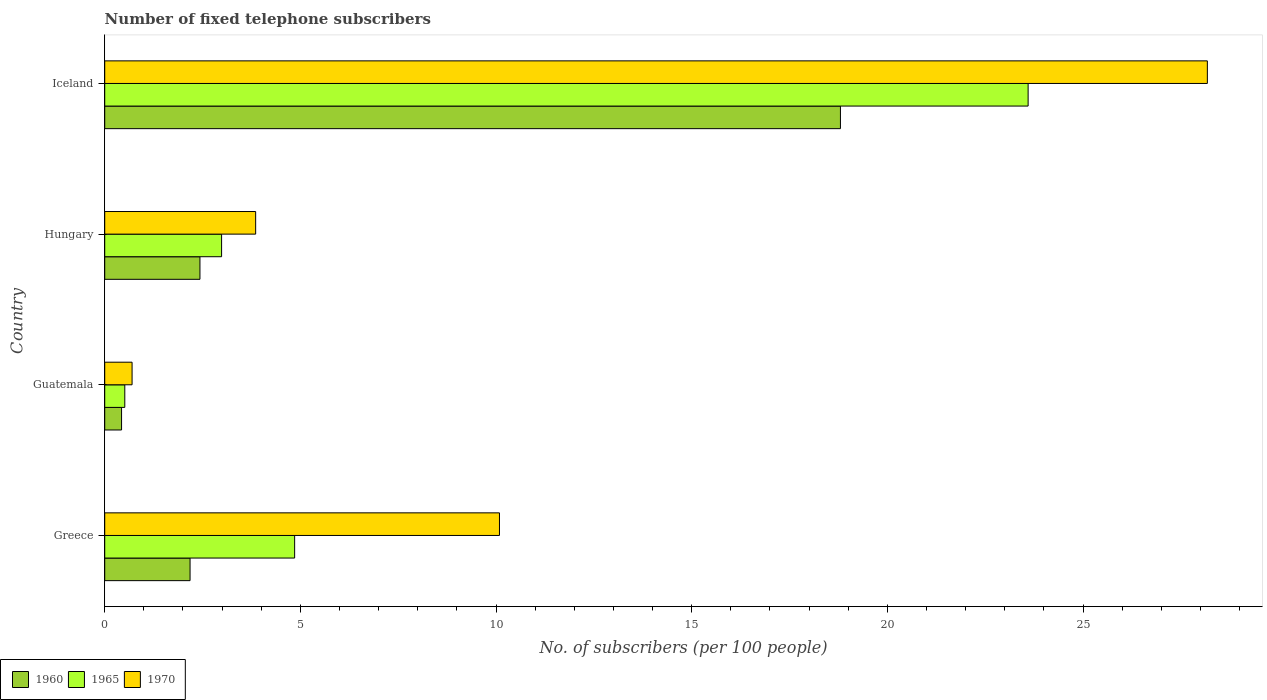How many different coloured bars are there?
Your response must be concise. 3. How many bars are there on the 4th tick from the bottom?
Your response must be concise. 3. What is the label of the 2nd group of bars from the top?
Make the answer very short. Hungary. In how many cases, is the number of bars for a given country not equal to the number of legend labels?
Offer a very short reply. 0. What is the number of fixed telephone subscribers in 1965 in Guatemala?
Ensure brevity in your answer.  0.51. Across all countries, what is the maximum number of fixed telephone subscribers in 1970?
Provide a succinct answer. 28.18. Across all countries, what is the minimum number of fixed telephone subscribers in 1965?
Your response must be concise. 0.51. In which country was the number of fixed telephone subscribers in 1960 maximum?
Offer a terse response. Iceland. In which country was the number of fixed telephone subscribers in 1965 minimum?
Provide a succinct answer. Guatemala. What is the total number of fixed telephone subscribers in 1970 in the graph?
Keep it short and to the point. 42.82. What is the difference between the number of fixed telephone subscribers in 1965 in Guatemala and that in Iceland?
Provide a succinct answer. -23.08. What is the difference between the number of fixed telephone subscribers in 1970 in Guatemala and the number of fixed telephone subscribers in 1965 in Greece?
Ensure brevity in your answer.  -4.15. What is the average number of fixed telephone subscribers in 1960 per country?
Your response must be concise. 5.96. What is the difference between the number of fixed telephone subscribers in 1960 and number of fixed telephone subscribers in 1970 in Iceland?
Offer a terse response. -9.38. In how many countries, is the number of fixed telephone subscribers in 1970 greater than 26 ?
Your response must be concise. 1. What is the ratio of the number of fixed telephone subscribers in 1970 in Greece to that in Guatemala?
Keep it short and to the point. 14.43. Is the number of fixed telephone subscribers in 1965 in Greece less than that in Hungary?
Give a very brief answer. No. What is the difference between the highest and the second highest number of fixed telephone subscribers in 1960?
Offer a very short reply. 16.37. What is the difference between the highest and the lowest number of fixed telephone subscribers in 1960?
Provide a succinct answer. 18.37. What does the 3rd bar from the bottom in Greece represents?
Provide a succinct answer. 1970. How many bars are there?
Your response must be concise. 12. Are all the bars in the graph horizontal?
Offer a very short reply. Yes. How many countries are there in the graph?
Ensure brevity in your answer.  4. Does the graph contain any zero values?
Provide a short and direct response. No. How many legend labels are there?
Offer a terse response. 3. What is the title of the graph?
Offer a terse response. Number of fixed telephone subscribers. Does "2011" appear as one of the legend labels in the graph?
Your answer should be very brief. No. What is the label or title of the X-axis?
Ensure brevity in your answer.  No. of subscribers (per 100 people). What is the label or title of the Y-axis?
Make the answer very short. Country. What is the No. of subscribers (per 100 people) in 1960 in Greece?
Provide a succinct answer. 2.18. What is the No. of subscribers (per 100 people) of 1965 in Greece?
Provide a succinct answer. 4.85. What is the No. of subscribers (per 100 people) of 1970 in Greece?
Provide a short and direct response. 10.09. What is the No. of subscribers (per 100 people) in 1960 in Guatemala?
Your answer should be compact. 0.43. What is the No. of subscribers (per 100 people) in 1965 in Guatemala?
Make the answer very short. 0.51. What is the No. of subscribers (per 100 people) in 1970 in Guatemala?
Provide a succinct answer. 0.7. What is the No. of subscribers (per 100 people) in 1960 in Hungary?
Your answer should be very brief. 2.43. What is the No. of subscribers (per 100 people) in 1965 in Hungary?
Keep it short and to the point. 2.99. What is the No. of subscribers (per 100 people) of 1970 in Hungary?
Your answer should be very brief. 3.86. What is the No. of subscribers (per 100 people) of 1960 in Iceland?
Your response must be concise. 18.8. What is the No. of subscribers (per 100 people) of 1965 in Iceland?
Provide a succinct answer. 23.6. What is the No. of subscribers (per 100 people) of 1970 in Iceland?
Ensure brevity in your answer.  28.18. Across all countries, what is the maximum No. of subscribers (per 100 people) in 1960?
Your response must be concise. 18.8. Across all countries, what is the maximum No. of subscribers (per 100 people) in 1965?
Your answer should be compact. 23.6. Across all countries, what is the maximum No. of subscribers (per 100 people) in 1970?
Keep it short and to the point. 28.18. Across all countries, what is the minimum No. of subscribers (per 100 people) of 1960?
Your answer should be compact. 0.43. Across all countries, what is the minimum No. of subscribers (per 100 people) of 1965?
Keep it short and to the point. 0.51. Across all countries, what is the minimum No. of subscribers (per 100 people) in 1970?
Your answer should be compact. 0.7. What is the total No. of subscribers (per 100 people) of 1960 in the graph?
Keep it short and to the point. 23.85. What is the total No. of subscribers (per 100 people) of 1965 in the graph?
Make the answer very short. 31.95. What is the total No. of subscribers (per 100 people) in 1970 in the graph?
Your answer should be very brief. 42.82. What is the difference between the No. of subscribers (per 100 people) of 1960 in Greece and that in Guatemala?
Your response must be concise. 1.75. What is the difference between the No. of subscribers (per 100 people) of 1965 in Greece and that in Guatemala?
Make the answer very short. 4.34. What is the difference between the No. of subscribers (per 100 people) in 1970 in Greece and that in Guatemala?
Offer a terse response. 9.39. What is the difference between the No. of subscribers (per 100 people) of 1960 in Greece and that in Hungary?
Offer a terse response. -0.25. What is the difference between the No. of subscribers (per 100 people) in 1965 in Greece and that in Hungary?
Offer a very short reply. 1.87. What is the difference between the No. of subscribers (per 100 people) in 1970 in Greece and that in Hungary?
Provide a short and direct response. 6.23. What is the difference between the No. of subscribers (per 100 people) in 1960 in Greece and that in Iceland?
Provide a short and direct response. -16.62. What is the difference between the No. of subscribers (per 100 people) in 1965 in Greece and that in Iceland?
Keep it short and to the point. -18.74. What is the difference between the No. of subscribers (per 100 people) of 1970 in Greece and that in Iceland?
Your answer should be very brief. -18.09. What is the difference between the No. of subscribers (per 100 people) of 1960 in Guatemala and that in Hungary?
Your response must be concise. -2. What is the difference between the No. of subscribers (per 100 people) in 1965 in Guatemala and that in Hungary?
Offer a very short reply. -2.47. What is the difference between the No. of subscribers (per 100 people) in 1970 in Guatemala and that in Hungary?
Ensure brevity in your answer.  -3.16. What is the difference between the No. of subscribers (per 100 people) in 1960 in Guatemala and that in Iceland?
Make the answer very short. -18.37. What is the difference between the No. of subscribers (per 100 people) of 1965 in Guatemala and that in Iceland?
Your answer should be very brief. -23.08. What is the difference between the No. of subscribers (per 100 people) of 1970 in Guatemala and that in Iceland?
Provide a short and direct response. -27.48. What is the difference between the No. of subscribers (per 100 people) of 1960 in Hungary and that in Iceland?
Give a very brief answer. -16.37. What is the difference between the No. of subscribers (per 100 people) in 1965 in Hungary and that in Iceland?
Give a very brief answer. -20.61. What is the difference between the No. of subscribers (per 100 people) in 1970 in Hungary and that in Iceland?
Your answer should be compact. -24.32. What is the difference between the No. of subscribers (per 100 people) of 1960 in Greece and the No. of subscribers (per 100 people) of 1965 in Guatemala?
Provide a short and direct response. 1.67. What is the difference between the No. of subscribers (per 100 people) of 1960 in Greece and the No. of subscribers (per 100 people) of 1970 in Guatemala?
Ensure brevity in your answer.  1.48. What is the difference between the No. of subscribers (per 100 people) in 1965 in Greece and the No. of subscribers (per 100 people) in 1970 in Guatemala?
Provide a short and direct response. 4.15. What is the difference between the No. of subscribers (per 100 people) of 1960 in Greece and the No. of subscribers (per 100 people) of 1965 in Hungary?
Your answer should be compact. -0.81. What is the difference between the No. of subscribers (per 100 people) of 1960 in Greece and the No. of subscribers (per 100 people) of 1970 in Hungary?
Your answer should be very brief. -1.68. What is the difference between the No. of subscribers (per 100 people) of 1965 in Greece and the No. of subscribers (per 100 people) of 1970 in Hungary?
Your answer should be very brief. 1. What is the difference between the No. of subscribers (per 100 people) in 1960 in Greece and the No. of subscribers (per 100 people) in 1965 in Iceland?
Offer a terse response. -21.42. What is the difference between the No. of subscribers (per 100 people) of 1960 in Greece and the No. of subscribers (per 100 people) of 1970 in Iceland?
Make the answer very short. -26. What is the difference between the No. of subscribers (per 100 people) in 1965 in Greece and the No. of subscribers (per 100 people) in 1970 in Iceland?
Offer a very short reply. -23.32. What is the difference between the No. of subscribers (per 100 people) of 1960 in Guatemala and the No. of subscribers (per 100 people) of 1965 in Hungary?
Keep it short and to the point. -2.56. What is the difference between the No. of subscribers (per 100 people) in 1960 in Guatemala and the No. of subscribers (per 100 people) in 1970 in Hungary?
Your response must be concise. -3.43. What is the difference between the No. of subscribers (per 100 people) in 1965 in Guatemala and the No. of subscribers (per 100 people) in 1970 in Hungary?
Your response must be concise. -3.34. What is the difference between the No. of subscribers (per 100 people) of 1960 in Guatemala and the No. of subscribers (per 100 people) of 1965 in Iceland?
Provide a short and direct response. -23.17. What is the difference between the No. of subscribers (per 100 people) in 1960 in Guatemala and the No. of subscribers (per 100 people) in 1970 in Iceland?
Your response must be concise. -27.75. What is the difference between the No. of subscribers (per 100 people) in 1965 in Guatemala and the No. of subscribers (per 100 people) in 1970 in Iceland?
Give a very brief answer. -27.66. What is the difference between the No. of subscribers (per 100 people) of 1960 in Hungary and the No. of subscribers (per 100 people) of 1965 in Iceland?
Offer a terse response. -21.16. What is the difference between the No. of subscribers (per 100 people) in 1960 in Hungary and the No. of subscribers (per 100 people) in 1970 in Iceland?
Offer a terse response. -25.74. What is the difference between the No. of subscribers (per 100 people) in 1965 in Hungary and the No. of subscribers (per 100 people) in 1970 in Iceland?
Offer a very short reply. -25.19. What is the average No. of subscribers (per 100 people) in 1960 per country?
Your response must be concise. 5.96. What is the average No. of subscribers (per 100 people) of 1965 per country?
Give a very brief answer. 7.99. What is the average No. of subscribers (per 100 people) of 1970 per country?
Give a very brief answer. 10.71. What is the difference between the No. of subscribers (per 100 people) in 1960 and No. of subscribers (per 100 people) in 1965 in Greece?
Offer a terse response. -2.67. What is the difference between the No. of subscribers (per 100 people) of 1960 and No. of subscribers (per 100 people) of 1970 in Greece?
Provide a short and direct response. -7.91. What is the difference between the No. of subscribers (per 100 people) in 1965 and No. of subscribers (per 100 people) in 1970 in Greece?
Your answer should be very brief. -5.23. What is the difference between the No. of subscribers (per 100 people) of 1960 and No. of subscribers (per 100 people) of 1965 in Guatemala?
Keep it short and to the point. -0.08. What is the difference between the No. of subscribers (per 100 people) of 1960 and No. of subscribers (per 100 people) of 1970 in Guatemala?
Your answer should be very brief. -0.27. What is the difference between the No. of subscribers (per 100 people) of 1965 and No. of subscribers (per 100 people) of 1970 in Guatemala?
Ensure brevity in your answer.  -0.19. What is the difference between the No. of subscribers (per 100 people) in 1960 and No. of subscribers (per 100 people) in 1965 in Hungary?
Give a very brief answer. -0.55. What is the difference between the No. of subscribers (per 100 people) of 1960 and No. of subscribers (per 100 people) of 1970 in Hungary?
Ensure brevity in your answer.  -1.42. What is the difference between the No. of subscribers (per 100 people) in 1965 and No. of subscribers (per 100 people) in 1970 in Hungary?
Keep it short and to the point. -0.87. What is the difference between the No. of subscribers (per 100 people) in 1960 and No. of subscribers (per 100 people) in 1965 in Iceland?
Provide a short and direct response. -4.8. What is the difference between the No. of subscribers (per 100 people) in 1960 and No. of subscribers (per 100 people) in 1970 in Iceland?
Your answer should be compact. -9.38. What is the difference between the No. of subscribers (per 100 people) in 1965 and No. of subscribers (per 100 people) in 1970 in Iceland?
Your response must be concise. -4.58. What is the ratio of the No. of subscribers (per 100 people) in 1960 in Greece to that in Guatemala?
Give a very brief answer. 5.07. What is the ratio of the No. of subscribers (per 100 people) in 1965 in Greece to that in Guatemala?
Provide a succinct answer. 9.46. What is the ratio of the No. of subscribers (per 100 people) in 1970 in Greece to that in Guatemala?
Ensure brevity in your answer.  14.43. What is the ratio of the No. of subscribers (per 100 people) of 1960 in Greece to that in Hungary?
Offer a terse response. 0.9. What is the ratio of the No. of subscribers (per 100 people) in 1965 in Greece to that in Hungary?
Provide a short and direct response. 1.62. What is the ratio of the No. of subscribers (per 100 people) in 1970 in Greece to that in Hungary?
Ensure brevity in your answer.  2.62. What is the ratio of the No. of subscribers (per 100 people) of 1960 in Greece to that in Iceland?
Your response must be concise. 0.12. What is the ratio of the No. of subscribers (per 100 people) in 1965 in Greece to that in Iceland?
Provide a succinct answer. 0.21. What is the ratio of the No. of subscribers (per 100 people) in 1970 in Greece to that in Iceland?
Offer a very short reply. 0.36. What is the ratio of the No. of subscribers (per 100 people) in 1960 in Guatemala to that in Hungary?
Keep it short and to the point. 0.18. What is the ratio of the No. of subscribers (per 100 people) in 1965 in Guatemala to that in Hungary?
Give a very brief answer. 0.17. What is the ratio of the No. of subscribers (per 100 people) of 1970 in Guatemala to that in Hungary?
Your answer should be very brief. 0.18. What is the ratio of the No. of subscribers (per 100 people) in 1960 in Guatemala to that in Iceland?
Provide a short and direct response. 0.02. What is the ratio of the No. of subscribers (per 100 people) of 1965 in Guatemala to that in Iceland?
Keep it short and to the point. 0.02. What is the ratio of the No. of subscribers (per 100 people) in 1970 in Guatemala to that in Iceland?
Your response must be concise. 0.02. What is the ratio of the No. of subscribers (per 100 people) of 1960 in Hungary to that in Iceland?
Offer a terse response. 0.13. What is the ratio of the No. of subscribers (per 100 people) of 1965 in Hungary to that in Iceland?
Offer a very short reply. 0.13. What is the ratio of the No. of subscribers (per 100 people) of 1970 in Hungary to that in Iceland?
Give a very brief answer. 0.14. What is the difference between the highest and the second highest No. of subscribers (per 100 people) in 1960?
Your answer should be very brief. 16.37. What is the difference between the highest and the second highest No. of subscribers (per 100 people) in 1965?
Offer a terse response. 18.74. What is the difference between the highest and the second highest No. of subscribers (per 100 people) in 1970?
Give a very brief answer. 18.09. What is the difference between the highest and the lowest No. of subscribers (per 100 people) in 1960?
Give a very brief answer. 18.37. What is the difference between the highest and the lowest No. of subscribers (per 100 people) of 1965?
Your answer should be very brief. 23.08. What is the difference between the highest and the lowest No. of subscribers (per 100 people) of 1970?
Your answer should be compact. 27.48. 